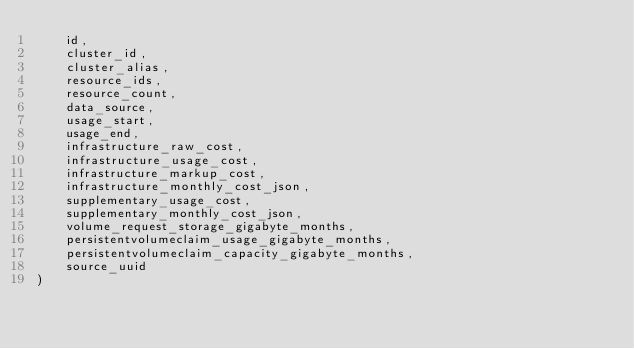Convert code to text. <code><loc_0><loc_0><loc_500><loc_500><_SQL_>    id,
    cluster_id,
    cluster_alias,
    resource_ids,
    resource_count,
    data_source,
    usage_start,
    usage_end,
    infrastructure_raw_cost,
    infrastructure_usage_cost,
    infrastructure_markup_cost,
    infrastructure_monthly_cost_json,
    supplementary_usage_cost,
    supplementary_monthly_cost_json,
    volume_request_storage_gigabyte_months,
    persistentvolumeclaim_usage_gigabyte_months,
    persistentvolumeclaim_capacity_gigabyte_months,
    source_uuid
)</code> 